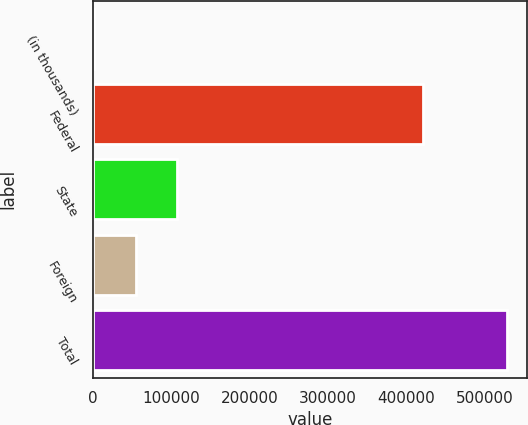<chart> <loc_0><loc_0><loc_500><loc_500><bar_chart><fcel>(in thousands)<fcel>Federal<fcel>State<fcel>Foreign<fcel>Total<nl><fcel>2005<fcel>421760<fcel>107235<fcel>54620<fcel>528155<nl></chart> 